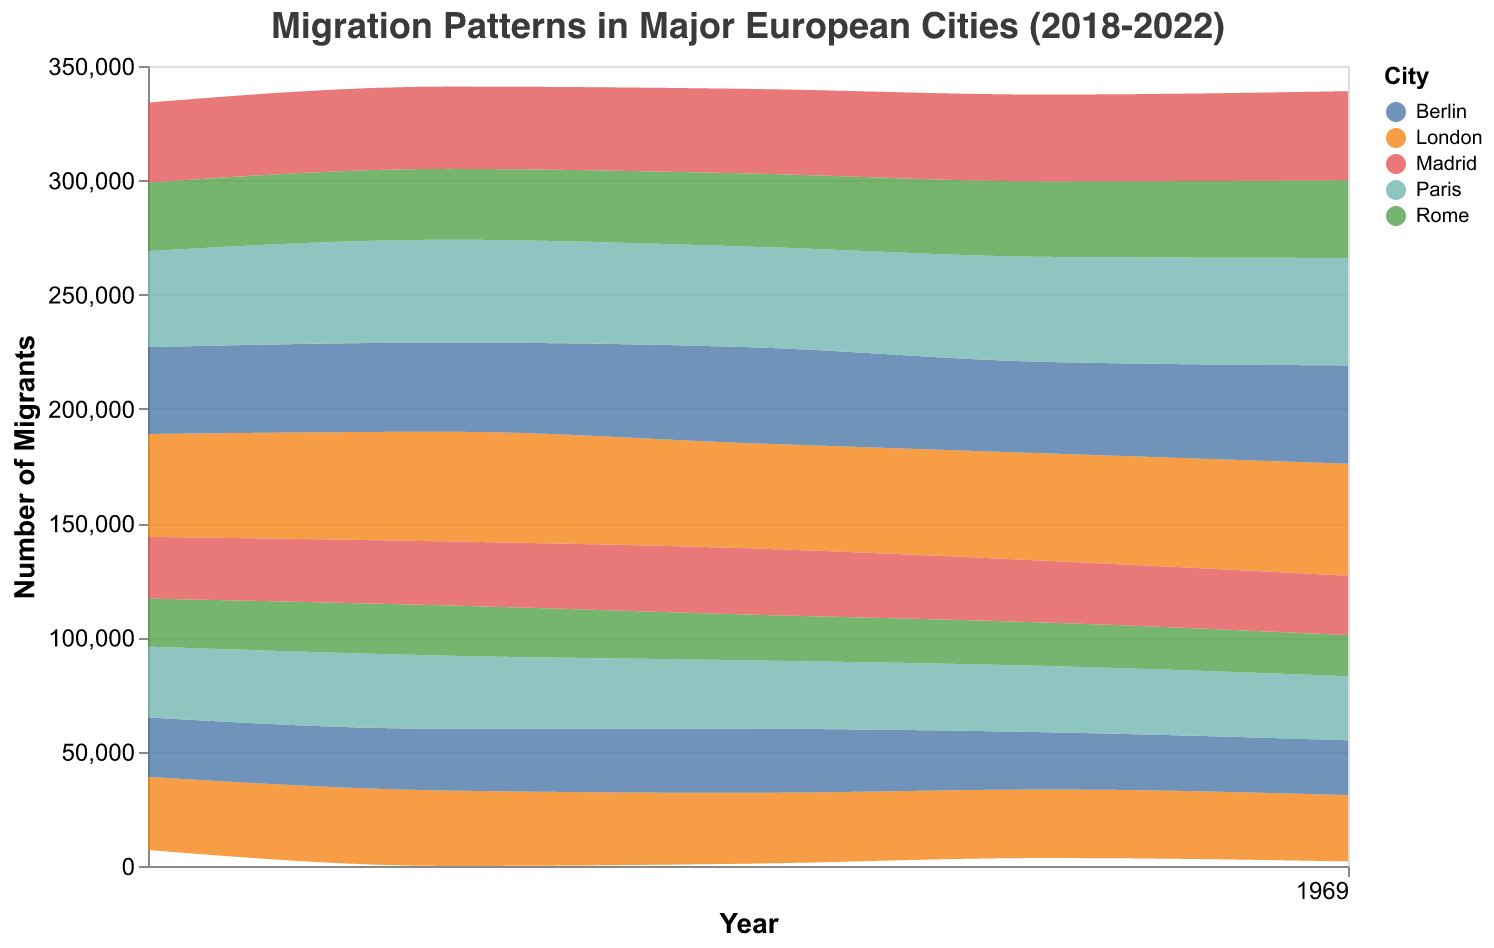What's the title of the figure? The title is written in a larger font size at the top center of the graph.
Answer: Migration Patterns in Major European Cities (2018-2022) How does the migration trend in London compare from 2018 to 2022 for incoming migrants? To determine the trend, observe the height of the incoming migration stream area for London from 2018 to 2022. It starts at 45,000 in 2018 and increases to 49,000 by 2022.
Answer: Incoming migration in London has increased What's the overall pattern for outgoing migration in Paris from 2018 to 2022? To identify the pattern, follow the outgoing migration stream area for Paris from 2018 to 2022 by looking at how the height changes each year. It starts from 31,000 and decreases to 28,000 over the period.
Answer: Outgoing migration in Paris has decreased Which city had the highest number of incoming migrants in 2022? Compare the height of the incoming migration stream areas for different cities in 2022. The city with the highest peak is London with 49,000 migrants.
Answer: London Is there a year where Berlin had more outgoing migrants than incoming migrants? Compare the heights of the incoming and outgoing migration stream areas for each year for Berlin. In all years, the incoming migration is higher than the outgoing.
Answer: No What's the trend of the outgoing migration in Rome from 2018 to 2022? Examine the height of the outgoing migration stream for Rome, which starts at 21,000 in 2018 and decreases to 18,000 by 2022.
Answer: Decreasing Which city had the lowest number of outgoing migrants in 2020? Compare the height of the outgoing migration stream areas for each city in 2020. The city with the lowest height is Rome with 20,000 migrants.
Answer: Rome Compare the difference in the number of incoming migrants between Madrid and Berlin in 2021. Look at the height of the incoming migration streams for Madrid and Berlin in 2021. Madrid has 38,000 and Berlin has 40,000. The difference is 40,000 - 38,000 = 2,000.
Answer: 2,000 How does the number of incoming migrants in Paris in 2020 compare to the number in Madrid in 2020? Check the height of the incoming migration streams for Paris and Madrid in 2020. Paris has 44,000, and Madrid has 37,000. Paris has more incoming migrants than Madrid in 2020.
Answer: Paris has more What’s the average number of incoming migrants in Berlin from 2018 to 2022? To find the average, sum the incoming migrants for Berlin for each year and divide by 5. (38,000 + 39,000 + 42,000 + 40,000 + 43,000) / 5 = 40,400.
Answer: 40,400 